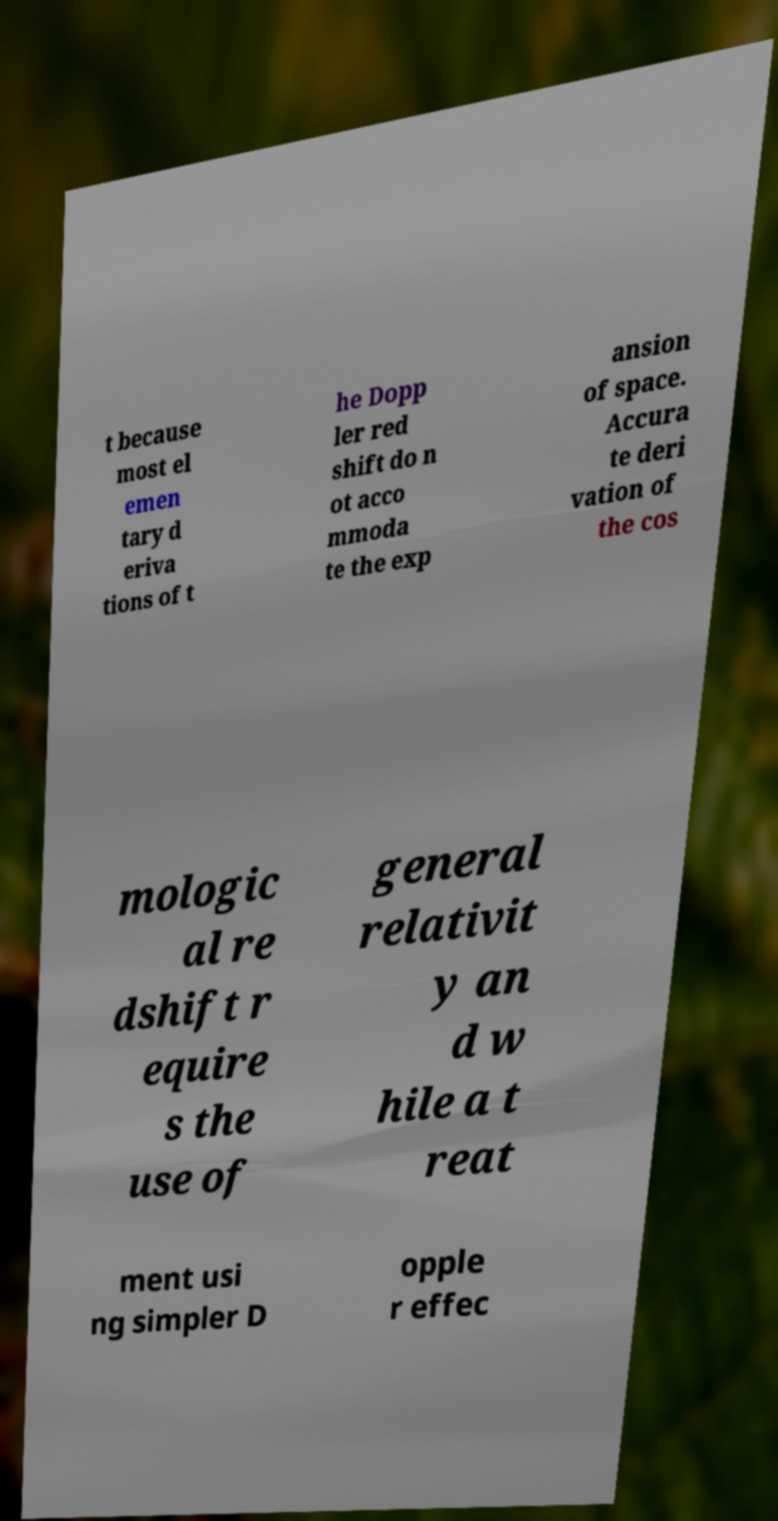Can you read and provide the text displayed in the image?This photo seems to have some interesting text. Can you extract and type it out for me? t because most el emen tary d eriva tions of t he Dopp ler red shift do n ot acco mmoda te the exp ansion of space. Accura te deri vation of the cos mologic al re dshift r equire s the use of general relativit y an d w hile a t reat ment usi ng simpler D opple r effec 